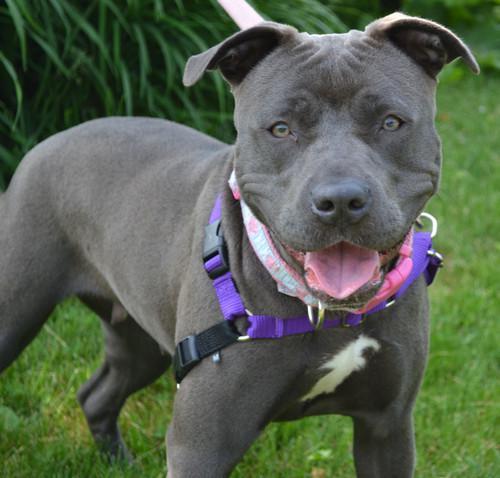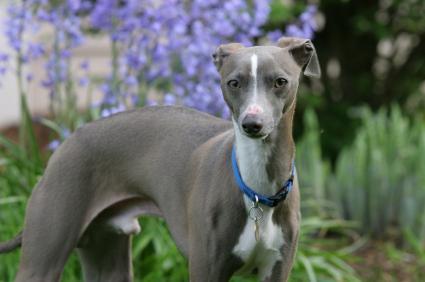The first image is the image on the left, the second image is the image on the right. For the images shown, is this caption "Each dog is posed outside with its head facing forward, and each dog wears a type of collar." true? Answer yes or no. Yes. The first image is the image on the left, the second image is the image on the right. Given the left and right images, does the statement "The dog in the left image is wearing a collar." hold true? Answer yes or no. Yes. 